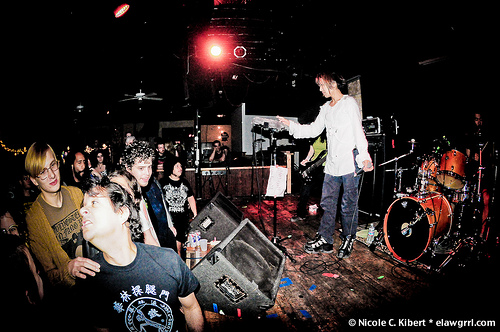<image>
Is there a girl on the stage? Yes. Looking at the image, I can see the girl is positioned on top of the stage, with the stage providing support. Is there a woman behind the drums? No. The woman is not behind the drums. From this viewpoint, the woman appears to be positioned elsewhere in the scene. 